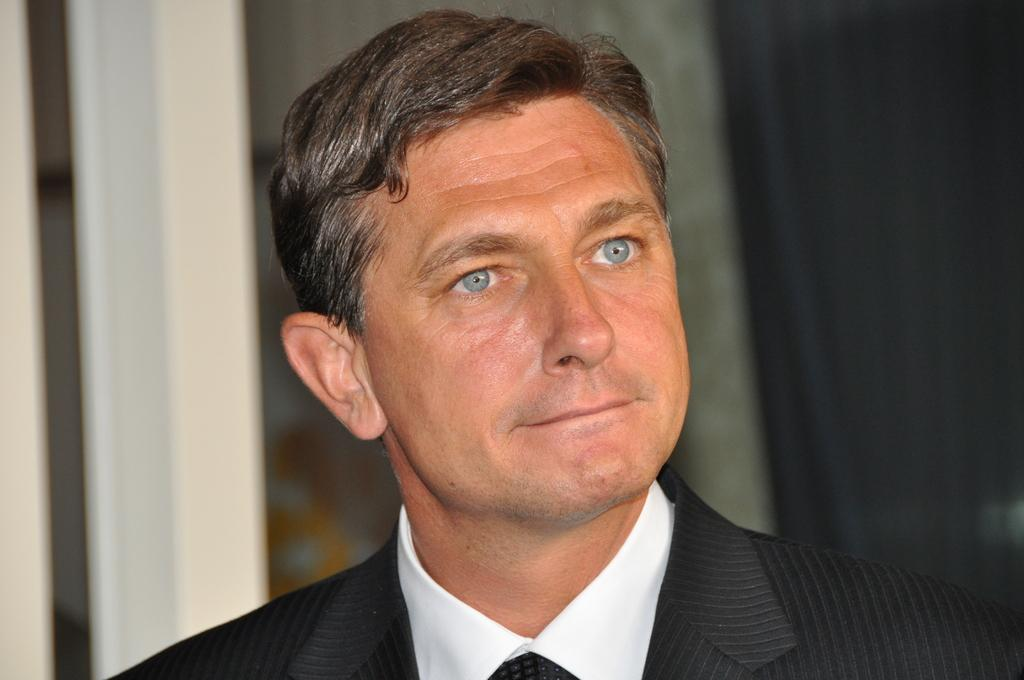Who is present in the image? There is a man in the image. What is the man wearing on his upper body? The man is wearing a shirt and a suit. Can you describe the background of the image? The background of the image appears blurry. What type of haircut does the man have in the image? There is no information about the man's haircut in the image. How many toes can be seen in the image? There are no visible toes in the image. 